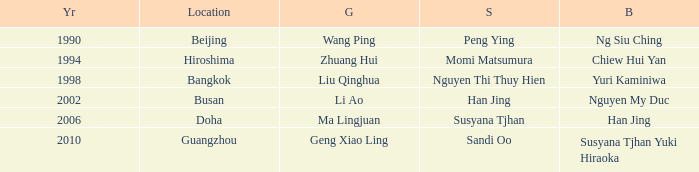What Silver has the Location of Guangzhou? Sandi Oo. 